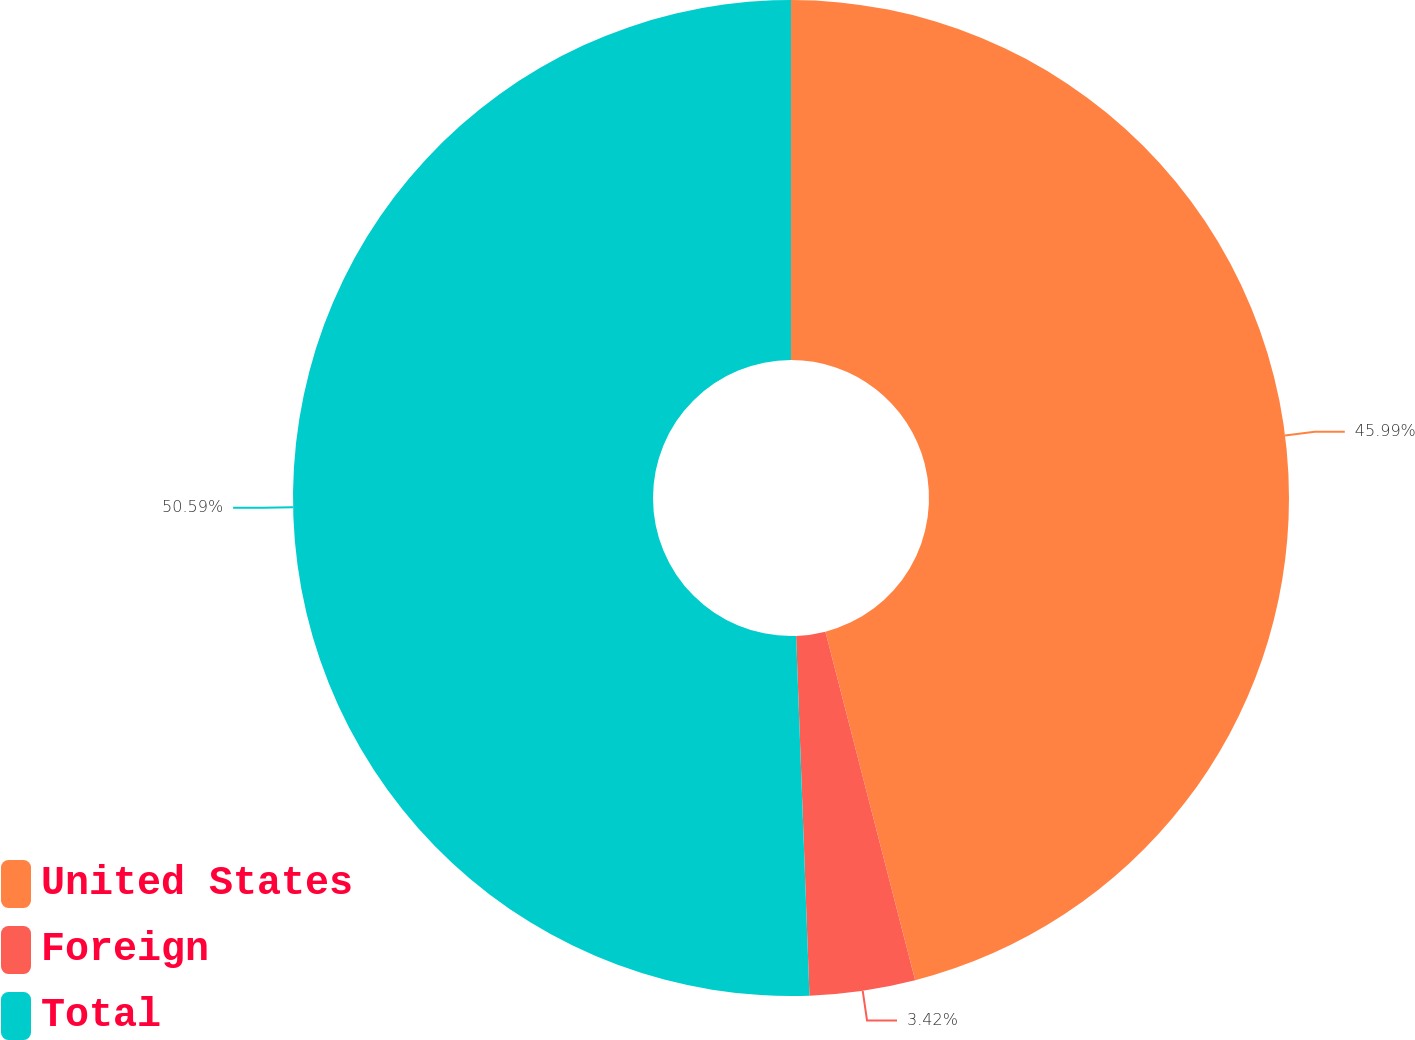Convert chart. <chart><loc_0><loc_0><loc_500><loc_500><pie_chart><fcel>United States<fcel>Foreign<fcel>Total<nl><fcel>45.99%<fcel>3.42%<fcel>50.59%<nl></chart> 